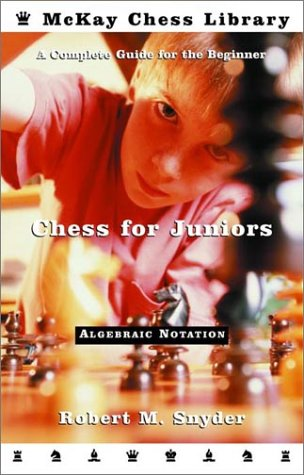Is this a comics book? No, this book is not a comic book. It is an instructive guide on chess, teaching the fundamentals and tactics of the game, primarily aimed at junior players. 